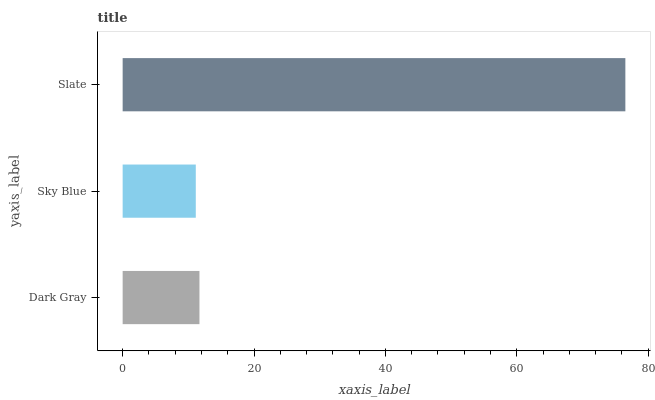Is Sky Blue the minimum?
Answer yes or no. Yes. Is Slate the maximum?
Answer yes or no. Yes. Is Slate the minimum?
Answer yes or no. No. Is Sky Blue the maximum?
Answer yes or no. No. Is Slate greater than Sky Blue?
Answer yes or no. Yes. Is Sky Blue less than Slate?
Answer yes or no. Yes. Is Sky Blue greater than Slate?
Answer yes or no. No. Is Slate less than Sky Blue?
Answer yes or no. No. Is Dark Gray the high median?
Answer yes or no. Yes. Is Dark Gray the low median?
Answer yes or no. Yes. Is Slate the high median?
Answer yes or no. No. Is Slate the low median?
Answer yes or no. No. 